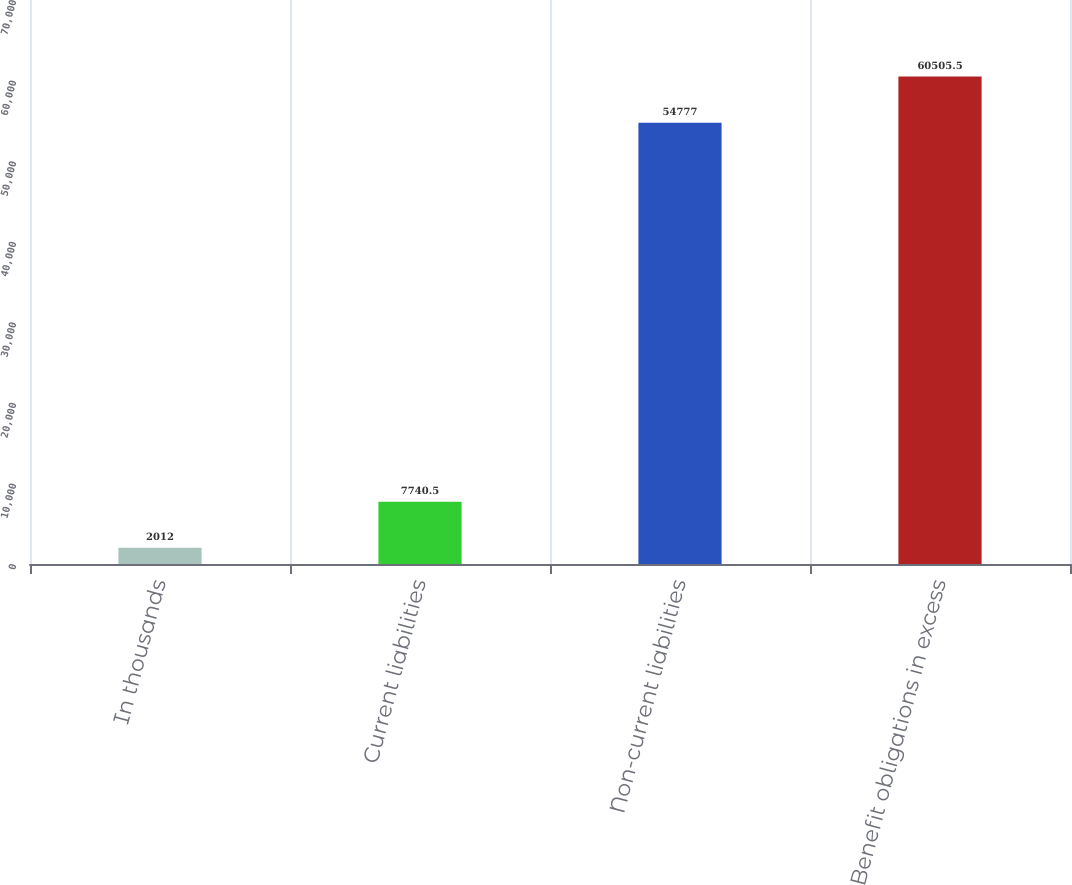Convert chart. <chart><loc_0><loc_0><loc_500><loc_500><bar_chart><fcel>In thousands<fcel>Current liabilities<fcel>Non-current liabilities<fcel>Benefit obligations in excess<nl><fcel>2012<fcel>7740.5<fcel>54777<fcel>60505.5<nl></chart> 